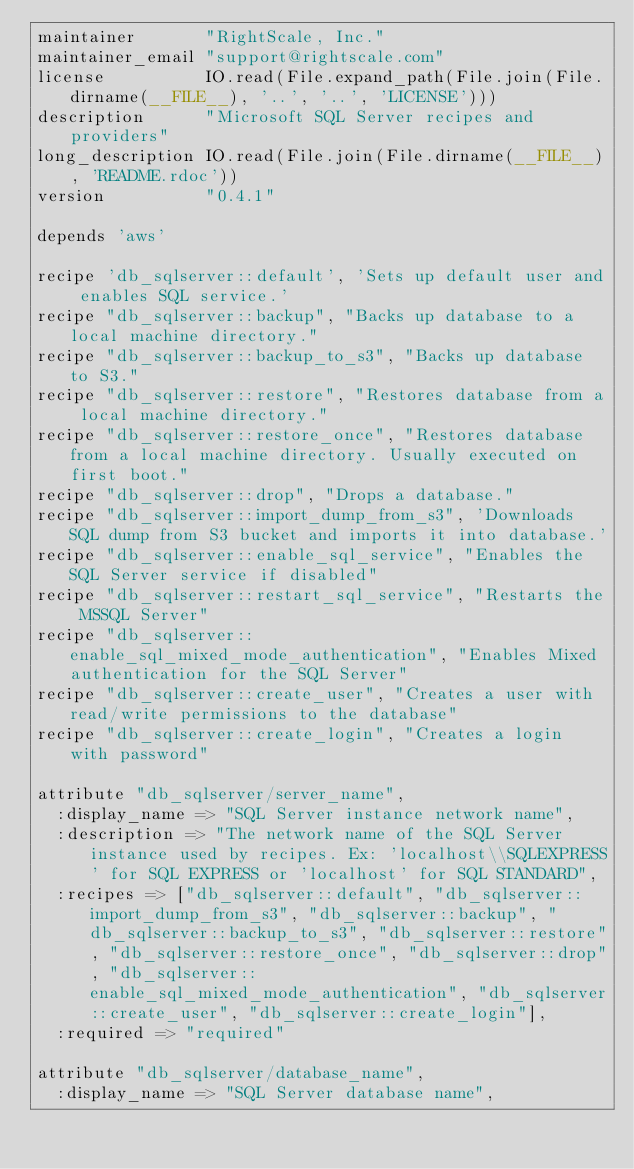Convert code to text. <code><loc_0><loc_0><loc_500><loc_500><_Ruby_>maintainer       "RightScale, Inc."
maintainer_email "support@rightscale.com"
license          IO.read(File.expand_path(File.join(File.dirname(__FILE__), '..', '..', 'LICENSE')))
description      "Microsoft SQL Server recipes and providers"
long_description IO.read(File.join(File.dirname(__FILE__), 'README.rdoc'))
version          "0.4.1"

depends 'aws'

recipe 'db_sqlserver::default', 'Sets up default user and enables SQL service.'
recipe "db_sqlserver::backup", "Backs up database to a local machine directory."
recipe "db_sqlserver::backup_to_s3", "Backs up database to S3."
recipe "db_sqlserver::restore", "Restores database from a local machine directory."
recipe "db_sqlserver::restore_once", "Restores database from a local machine directory. Usually executed on first boot."
recipe "db_sqlserver::drop", "Drops a database."
recipe "db_sqlserver::import_dump_from_s3", 'Downloads SQL dump from S3 bucket and imports it into database.'
recipe "db_sqlserver::enable_sql_service", "Enables the SQL Server service if disabled"
recipe "db_sqlserver::restart_sql_service", "Restarts the MSSQL Server"
recipe "db_sqlserver::enable_sql_mixed_mode_authentication", "Enables Mixed authentication for the SQL Server"
recipe "db_sqlserver::create_user", "Creates a user with read/write permissions to the database"
recipe "db_sqlserver::create_login", "Creates a login with password"

attribute "db_sqlserver/server_name",
  :display_name => "SQL Server instance network name",
  :description => "The network name of the SQL Server instance used by recipes. Ex: 'localhost\\SQLEXPRESS' for SQL EXPRESS or 'localhost' for SQL STANDARD",
  :recipes => ["db_sqlserver::default", "db_sqlserver::import_dump_from_s3", "db_sqlserver::backup", "db_sqlserver::backup_to_s3", "db_sqlserver::restore", "db_sqlserver::restore_once", "db_sqlserver::drop", "db_sqlserver::enable_sql_mixed_mode_authentication", "db_sqlserver::create_user", "db_sqlserver::create_login"],
  :required => "required"

attribute "db_sqlserver/database_name",
  :display_name => "SQL Server database name",</code> 